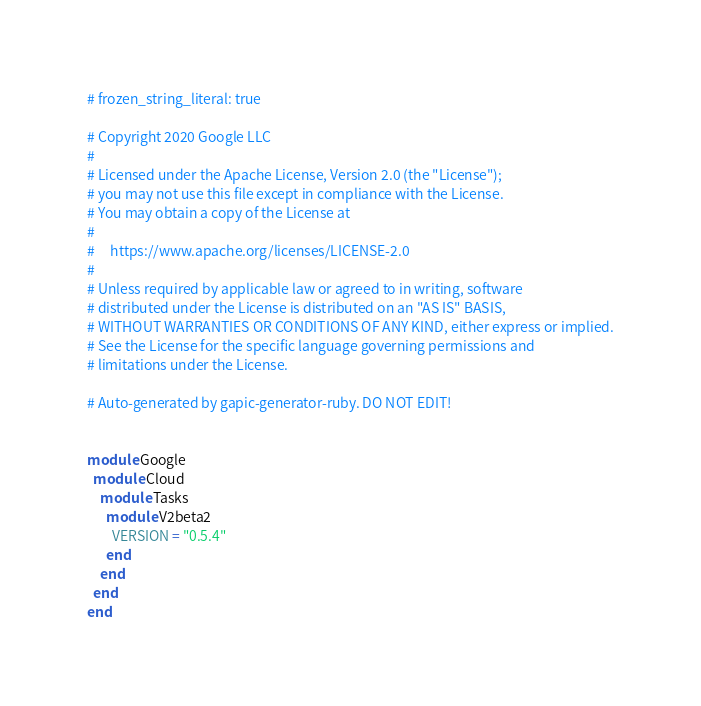<code> <loc_0><loc_0><loc_500><loc_500><_Ruby_># frozen_string_literal: true

# Copyright 2020 Google LLC
#
# Licensed under the Apache License, Version 2.0 (the "License");
# you may not use this file except in compliance with the License.
# You may obtain a copy of the License at
#
#     https://www.apache.org/licenses/LICENSE-2.0
#
# Unless required by applicable law or agreed to in writing, software
# distributed under the License is distributed on an "AS IS" BASIS,
# WITHOUT WARRANTIES OR CONDITIONS OF ANY KIND, either express or implied.
# See the License for the specific language governing permissions and
# limitations under the License.

# Auto-generated by gapic-generator-ruby. DO NOT EDIT!


module Google
  module Cloud
    module Tasks
      module V2beta2
        VERSION = "0.5.4"
      end
    end
  end
end
</code> 